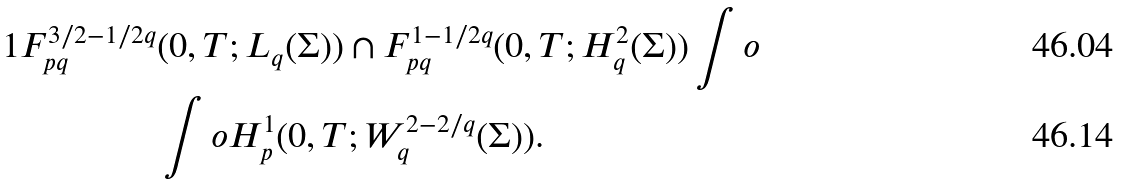Convert formula to latex. <formula><loc_0><loc_0><loc_500><loc_500>{ 1 } F ^ { 3 / 2 - 1 / 2 q } _ { p q } & ( 0 , T ; L _ { q } ( \Sigma ) ) \cap F ^ { 1 - 1 / 2 q } _ { p q } ( 0 , T ; H ^ { 2 } _ { q } ( \Sigma ) ) \int o \\ & \int o H ^ { 1 } _ { p } ( 0 , T ; W ^ { 2 - 2 / q } _ { q } ( \Sigma ) ) .</formula> 